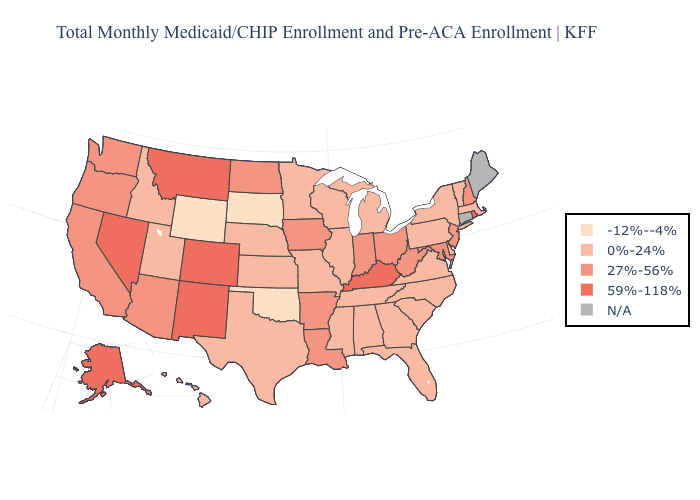Which states have the lowest value in the USA?
Short answer required. Oklahoma, South Dakota, Wyoming. What is the value of Missouri?
Concise answer only. 0%-24%. Name the states that have a value in the range N/A?
Keep it brief. Connecticut, Maine. Among the states that border North Dakota , does Montana have the lowest value?
Write a very short answer. No. Is the legend a continuous bar?
Short answer required. No. Does New Jersey have the highest value in the USA?
Concise answer only. No. Which states have the lowest value in the USA?
Keep it brief. Oklahoma, South Dakota, Wyoming. What is the value of Alabama?
Answer briefly. 0%-24%. What is the value of Iowa?
Give a very brief answer. 27%-56%. What is the highest value in the USA?
Keep it brief. 59%-118%. Name the states that have a value in the range 27%-56%?
Write a very short answer. Arizona, Arkansas, California, Indiana, Iowa, Louisiana, Maryland, New Hampshire, New Jersey, North Dakota, Ohio, Oregon, Washington, West Virginia. What is the lowest value in the Northeast?
Be succinct. 0%-24%. What is the value of Pennsylvania?
Keep it brief. 0%-24%. What is the value of Indiana?
Quick response, please. 27%-56%. 